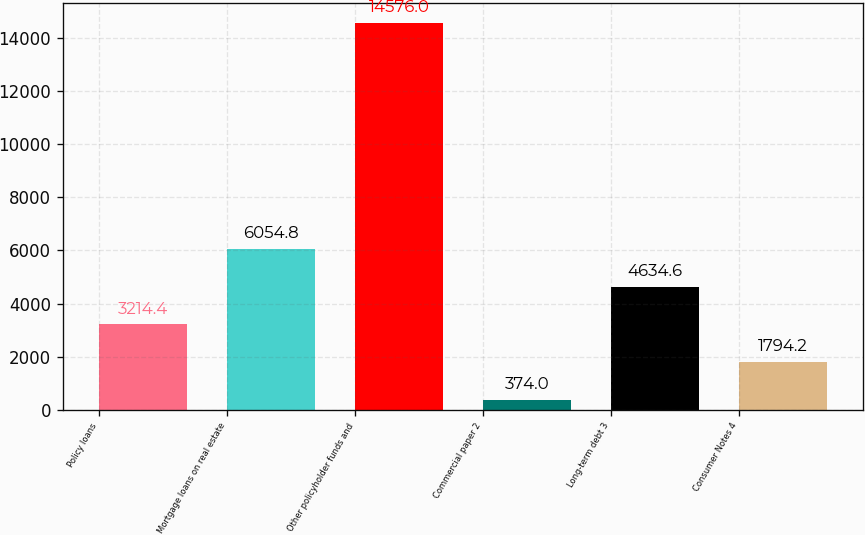Convert chart. <chart><loc_0><loc_0><loc_500><loc_500><bar_chart><fcel>Policy loans<fcel>Mortgage loans on real estate<fcel>Other policyholder funds and<fcel>Commercial paper 2<fcel>Long-term debt 3<fcel>Consumer Notes 4<nl><fcel>3214.4<fcel>6054.8<fcel>14576<fcel>374<fcel>4634.6<fcel>1794.2<nl></chart> 